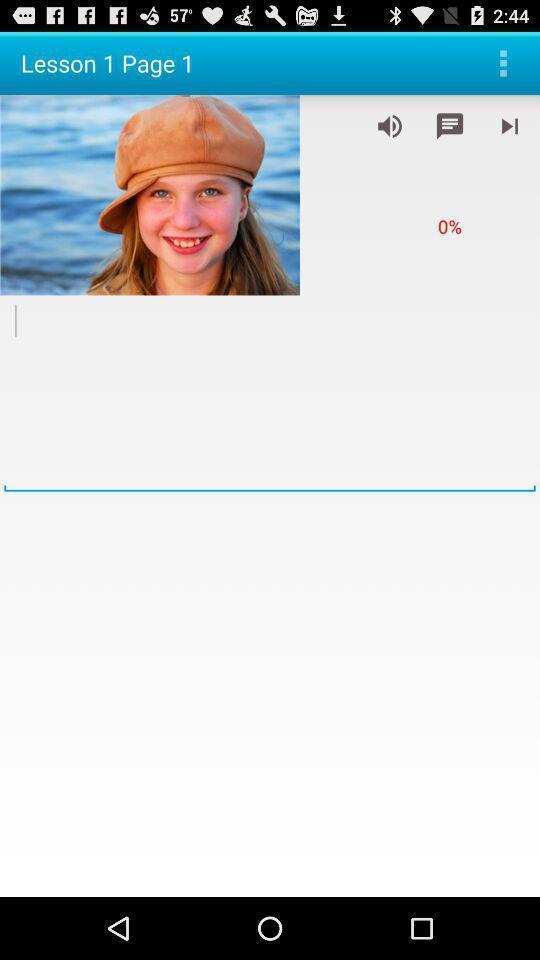Summarize the information in this screenshot. Screen displaying the lesson page. 